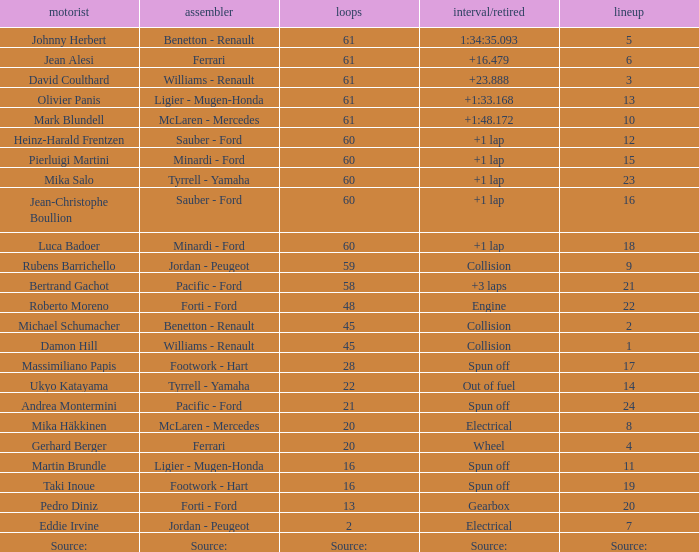How many laps does roberto moreno have? 48.0. 